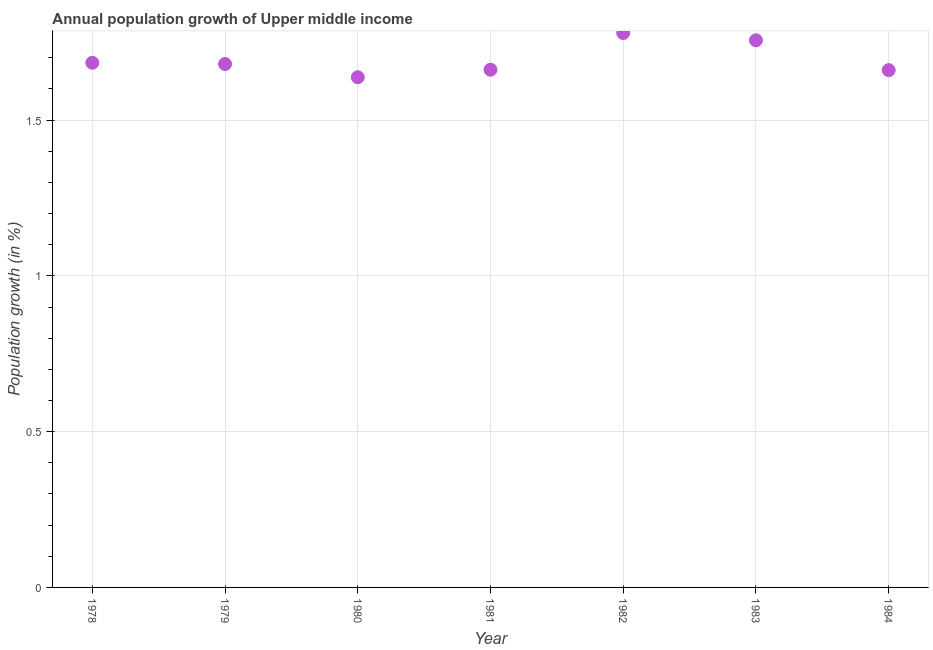What is the population growth in 1981?
Offer a terse response. 1.66. Across all years, what is the maximum population growth?
Make the answer very short. 1.78. Across all years, what is the minimum population growth?
Keep it short and to the point. 1.64. In which year was the population growth maximum?
Offer a very short reply. 1982. What is the sum of the population growth?
Provide a short and direct response. 11.86. What is the difference between the population growth in 1979 and 1984?
Your answer should be compact. 0.02. What is the average population growth per year?
Ensure brevity in your answer.  1.69. What is the median population growth?
Your answer should be compact. 1.68. In how many years, is the population growth greater than 0.30000000000000004 %?
Provide a succinct answer. 7. What is the ratio of the population growth in 1979 to that in 1983?
Offer a terse response. 0.96. What is the difference between the highest and the second highest population growth?
Your answer should be compact. 0.02. Is the sum of the population growth in 1978 and 1981 greater than the maximum population growth across all years?
Provide a short and direct response. Yes. What is the difference between the highest and the lowest population growth?
Provide a succinct answer. 0.14. Does the population growth monotonically increase over the years?
Provide a succinct answer. No. Does the graph contain grids?
Make the answer very short. Yes. What is the title of the graph?
Provide a short and direct response. Annual population growth of Upper middle income. What is the label or title of the X-axis?
Provide a succinct answer. Year. What is the label or title of the Y-axis?
Keep it short and to the point. Population growth (in %). What is the Population growth (in %) in 1978?
Offer a terse response. 1.68. What is the Population growth (in %) in 1979?
Provide a succinct answer. 1.68. What is the Population growth (in %) in 1980?
Keep it short and to the point. 1.64. What is the Population growth (in %) in 1981?
Ensure brevity in your answer.  1.66. What is the Population growth (in %) in 1982?
Provide a succinct answer. 1.78. What is the Population growth (in %) in 1983?
Your answer should be compact. 1.76. What is the Population growth (in %) in 1984?
Make the answer very short. 1.66. What is the difference between the Population growth (in %) in 1978 and 1979?
Provide a succinct answer. 0. What is the difference between the Population growth (in %) in 1978 and 1980?
Your response must be concise. 0.05. What is the difference between the Population growth (in %) in 1978 and 1981?
Provide a short and direct response. 0.02. What is the difference between the Population growth (in %) in 1978 and 1982?
Offer a very short reply. -0.1. What is the difference between the Population growth (in %) in 1978 and 1983?
Provide a succinct answer. -0.07. What is the difference between the Population growth (in %) in 1978 and 1984?
Give a very brief answer. 0.02. What is the difference between the Population growth (in %) in 1979 and 1980?
Make the answer very short. 0.04. What is the difference between the Population growth (in %) in 1979 and 1981?
Give a very brief answer. 0.02. What is the difference between the Population growth (in %) in 1979 and 1982?
Make the answer very short. -0.1. What is the difference between the Population growth (in %) in 1979 and 1983?
Make the answer very short. -0.08. What is the difference between the Population growth (in %) in 1979 and 1984?
Offer a terse response. 0.02. What is the difference between the Population growth (in %) in 1980 and 1981?
Offer a very short reply. -0.02. What is the difference between the Population growth (in %) in 1980 and 1982?
Offer a very short reply. -0.14. What is the difference between the Population growth (in %) in 1980 and 1983?
Your response must be concise. -0.12. What is the difference between the Population growth (in %) in 1980 and 1984?
Your answer should be very brief. -0.02. What is the difference between the Population growth (in %) in 1981 and 1982?
Your response must be concise. -0.12. What is the difference between the Population growth (in %) in 1981 and 1983?
Provide a short and direct response. -0.09. What is the difference between the Population growth (in %) in 1981 and 1984?
Ensure brevity in your answer.  0. What is the difference between the Population growth (in %) in 1982 and 1983?
Give a very brief answer. 0.02. What is the difference between the Population growth (in %) in 1982 and 1984?
Provide a short and direct response. 0.12. What is the difference between the Population growth (in %) in 1983 and 1984?
Keep it short and to the point. 0.1. What is the ratio of the Population growth (in %) in 1978 to that in 1979?
Keep it short and to the point. 1. What is the ratio of the Population growth (in %) in 1978 to that in 1980?
Your answer should be very brief. 1.03. What is the ratio of the Population growth (in %) in 1978 to that in 1981?
Your answer should be compact. 1.01. What is the ratio of the Population growth (in %) in 1978 to that in 1982?
Provide a short and direct response. 0.95. What is the ratio of the Population growth (in %) in 1979 to that in 1980?
Make the answer very short. 1.03. What is the ratio of the Population growth (in %) in 1979 to that in 1982?
Make the answer very short. 0.94. What is the ratio of the Population growth (in %) in 1980 to that in 1983?
Provide a succinct answer. 0.93. What is the ratio of the Population growth (in %) in 1981 to that in 1982?
Your answer should be very brief. 0.93. What is the ratio of the Population growth (in %) in 1981 to that in 1983?
Offer a very short reply. 0.95. What is the ratio of the Population growth (in %) in 1981 to that in 1984?
Make the answer very short. 1. What is the ratio of the Population growth (in %) in 1982 to that in 1984?
Give a very brief answer. 1.07. What is the ratio of the Population growth (in %) in 1983 to that in 1984?
Give a very brief answer. 1.06. 